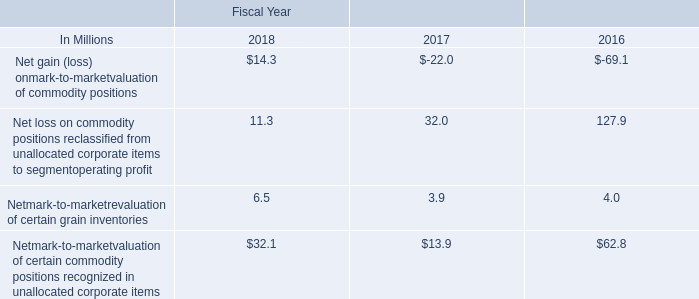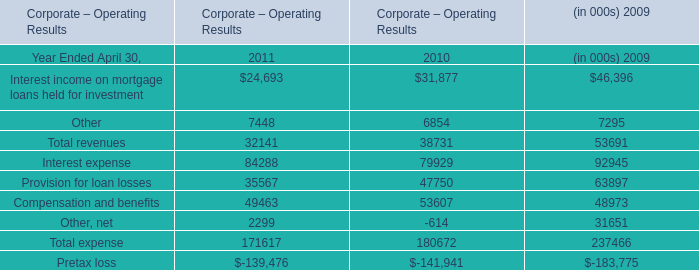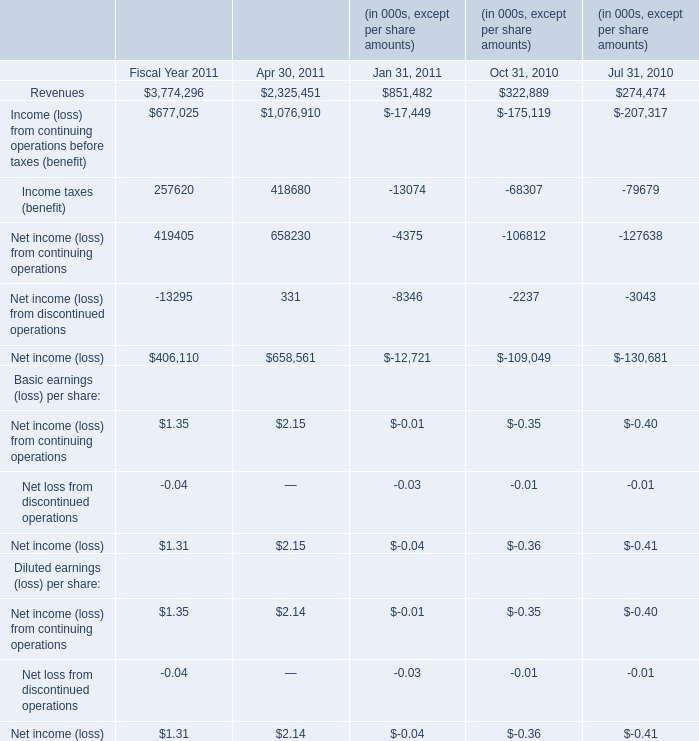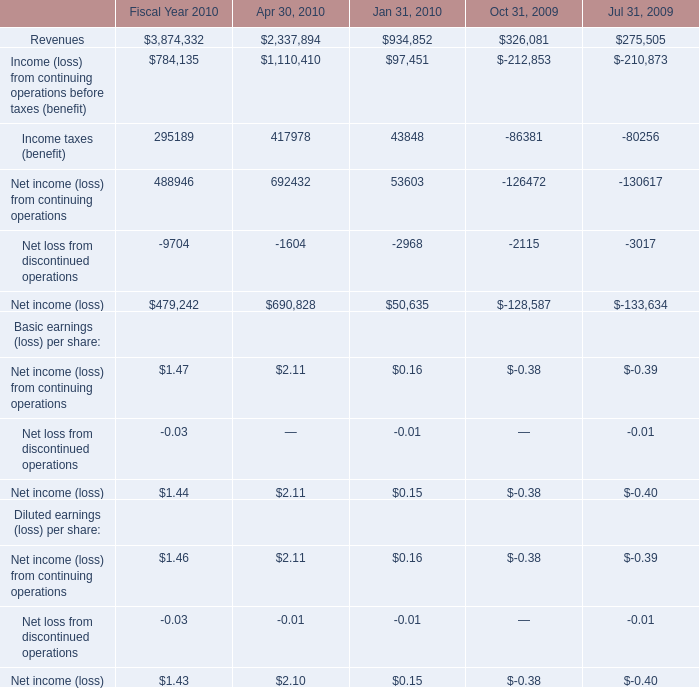What was the total amount of the Net income (loss) from continuing operations in the sections where Net loss from discontinued operations greater than -0.020? 
Computations: (0.16 - 0.39)
Answer: -0.23. 